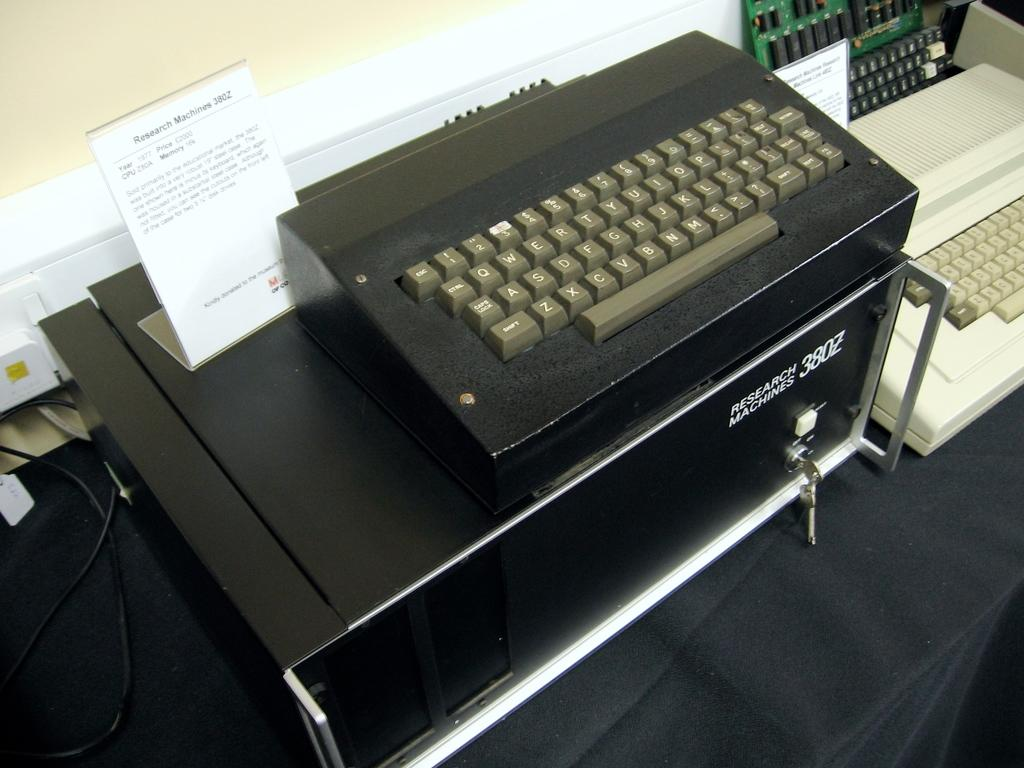Provide a one-sentence caption for the provided image. A keyboard that says Search Machines on it. 